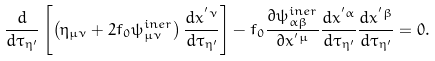<formula> <loc_0><loc_0><loc_500><loc_500>\frac { d } { d \tau _ { \eta ^ { \prime } } } \left [ \left ( \eta _ { \mu \nu } + 2 f _ { 0 } \psi ^ { i n e r } _ { \mu \nu } \right ) \frac { d x ^ { ^ { \prime } \nu } } { d \tau _ { \eta ^ { \prime } } } \right ] - f _ { 0 } \frac { \partial \psi ^ { i n e r } _ { \alpha \beta } } { \partial x ^ { ^ { \prime } \mu } } \frac { d x ^ { ^ { \prime } \alpha } } { d \tau _ { \eta ^ { \prime } } } \frac { d x ^ { ^ { \prime } \beta } } { d \tau _ { \eta ^ { \prime } } } = 0 .</formula> 